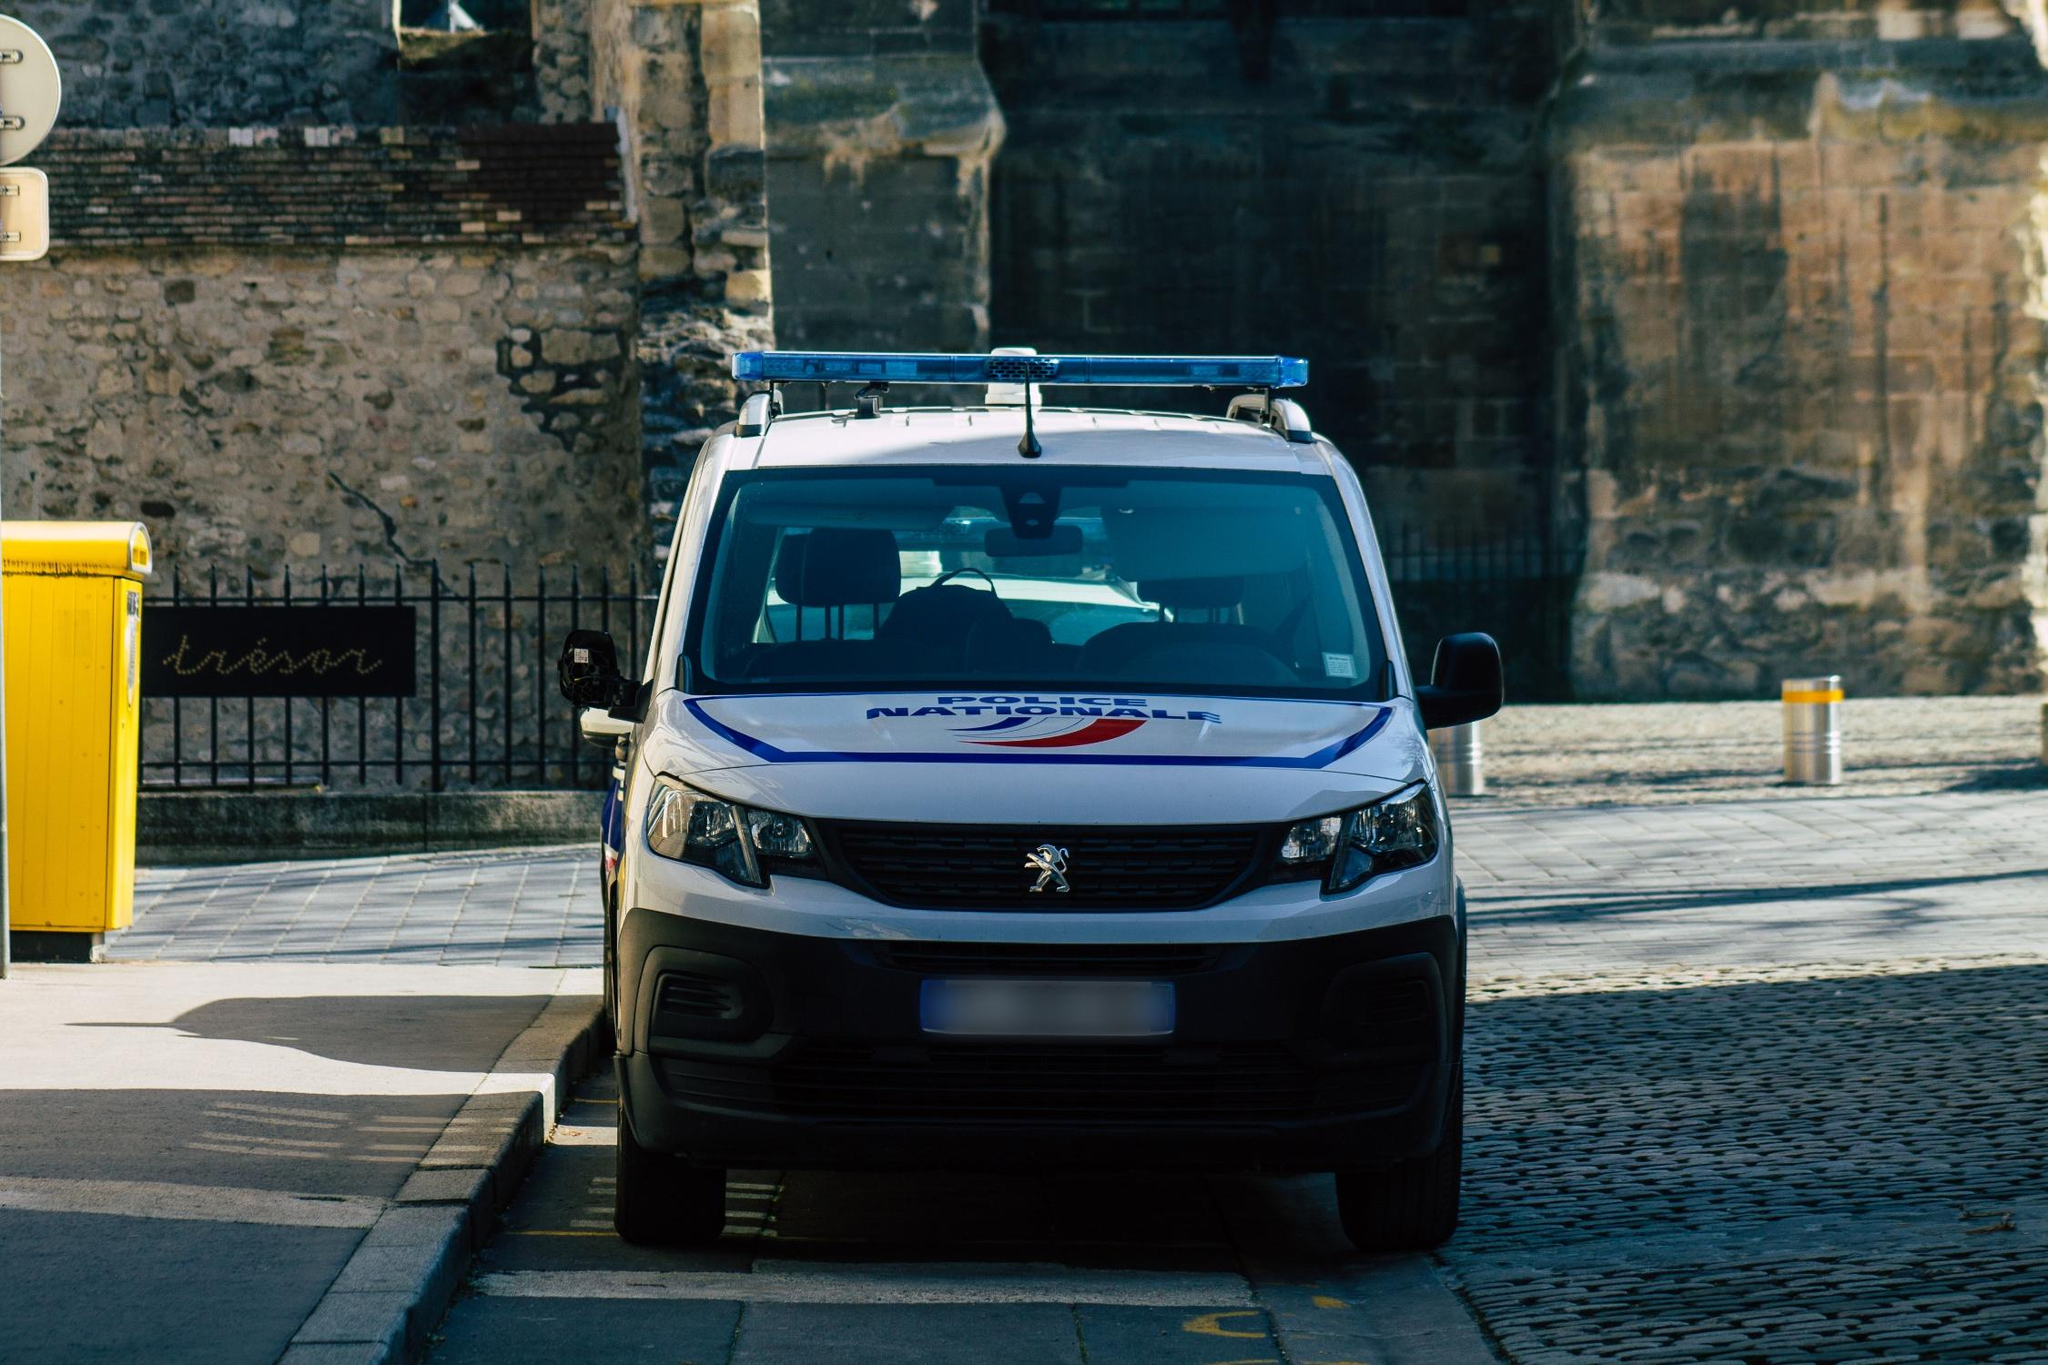Can you describe the historical elements visible in the environment around the van? Certainly, the historical elements are notable in the image's backdrop. The stone wall behind the van, made of uneven, weathered stones, suggests an older, perhaps medieval structure typical of historic European cities. Additionally, the cobblestone pavement enhances the old-world charm of the setting. The ornamental metal sign, although partially obscured, features script that hints at traditional craftsmanship, possibly serving a decorative or informational purpose. 